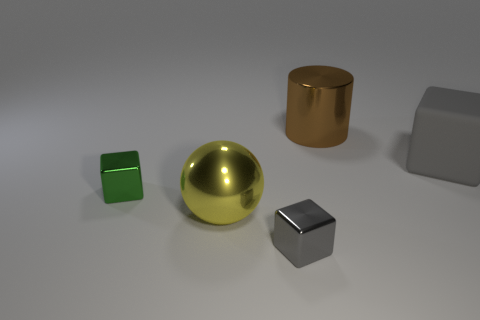Does the gray thing that is in front of the big gray rubber cube have the same size as the gray thing right of the brown metallic cylinder?
Your answer should be very brief. No. What is the shape of the thing behind the large gray matte object?
Offer a very short reply. Cylinder. There is a large thing that is the same shape as the tiny green shiny thing; what is its material?
Your answer should be very brief. Rubber. Do the gray thing in front of the gray rubber thing and the big metallic sphere have the same size?
Your answer should be very brief. No. How many gray cubes are on the right side of the yellow thing?
Your answer should be compact. 2. Are there fewer gray cubes behind the green metal block than large balls that are on the right side of the rubber cube?
Ensure brevity in your answer.  No. What number of gray shiny balls are there?
Your answer should be compact. 0. There is a shiny thing that is to the right of the small gray metallic thing; what is its color?
Offer a very short reply. Brown. The gray rubber thing is what size?
Offer a terse response. Large. Do the large rubber object and the large shiny object that is on the left side of the metal cylinder have the same color?
Your answer should be compact. No. 